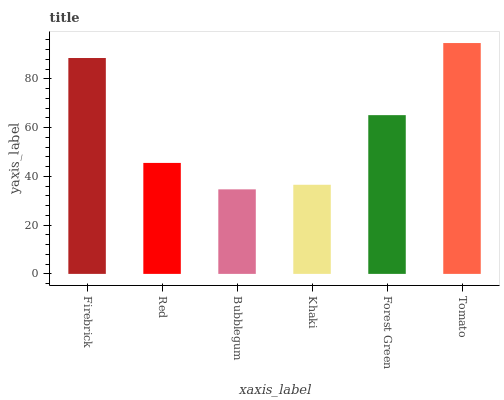Is Bubblegum the minimum?
Answer yes or no. Yes. Is Tomato the maximum?
Answer yes or no. Yes. Is Red the minimum?
Answer yes or no. No. Is Red the maximum?
Answer yes or no. No. Is Firebrick greater than Red?
Answer yes or no. Yes. Is Red less than Firebrick?
Answer yes or no. Yes. Is Red greater than Firebrick?
Answer yes or no. No. Is Firebrick less than Red?
Answer yes or no. No. Is Forest Green the high median?
Answer yes or no. Yes. Is Red the low median?
Answer yes or no. Yes. Is Khaki the high median?
Answer yes or no. No. Is Tomato the low median?
Answer yes or no. No. 